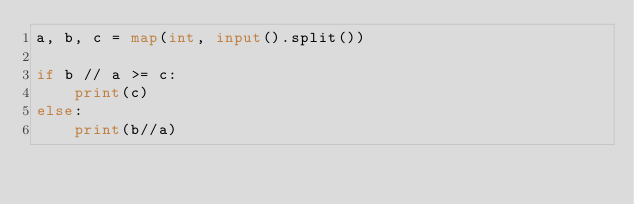Convert code to text. <code><loc_0><loc_0><loc_500><loc_500><_Python_>a, b, c = map(int, input().split())

if b // a >= c:
    print(c)
else:
    print(b//a)</code> 